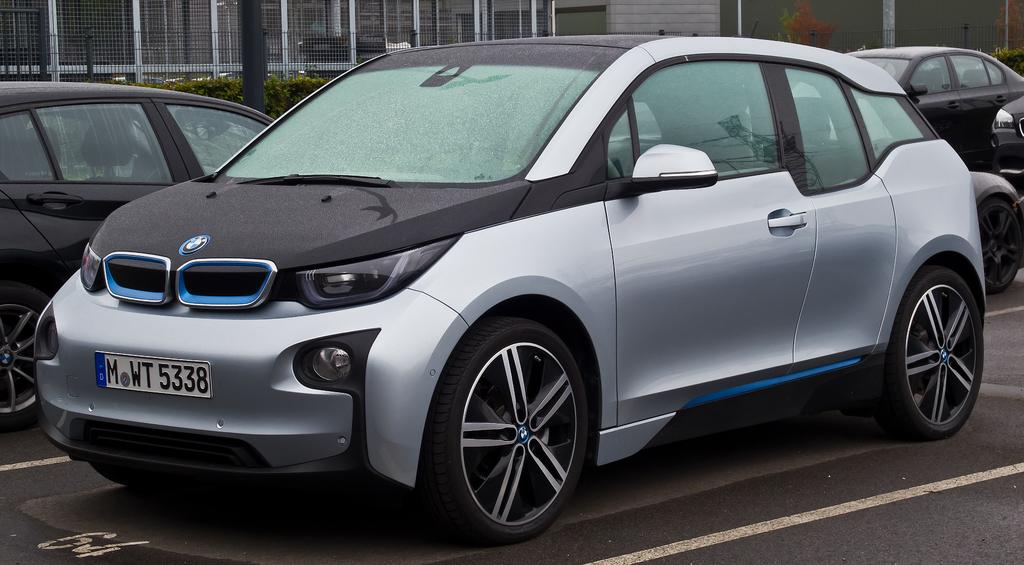What can be seen on the road in the image? There are cars on the road in the image. What is visible in the background of the image? There is a building, trees, a fence, and a pole in the background of the image. How many spiders are crawling on the cars in the image? There are no spiders present in the image; it features cars on the road with a background of a building, trees, a fence, and a pole. What type of butter is being used to paint the building in the image? There is no butter present in the image, and the building is not being painted. 